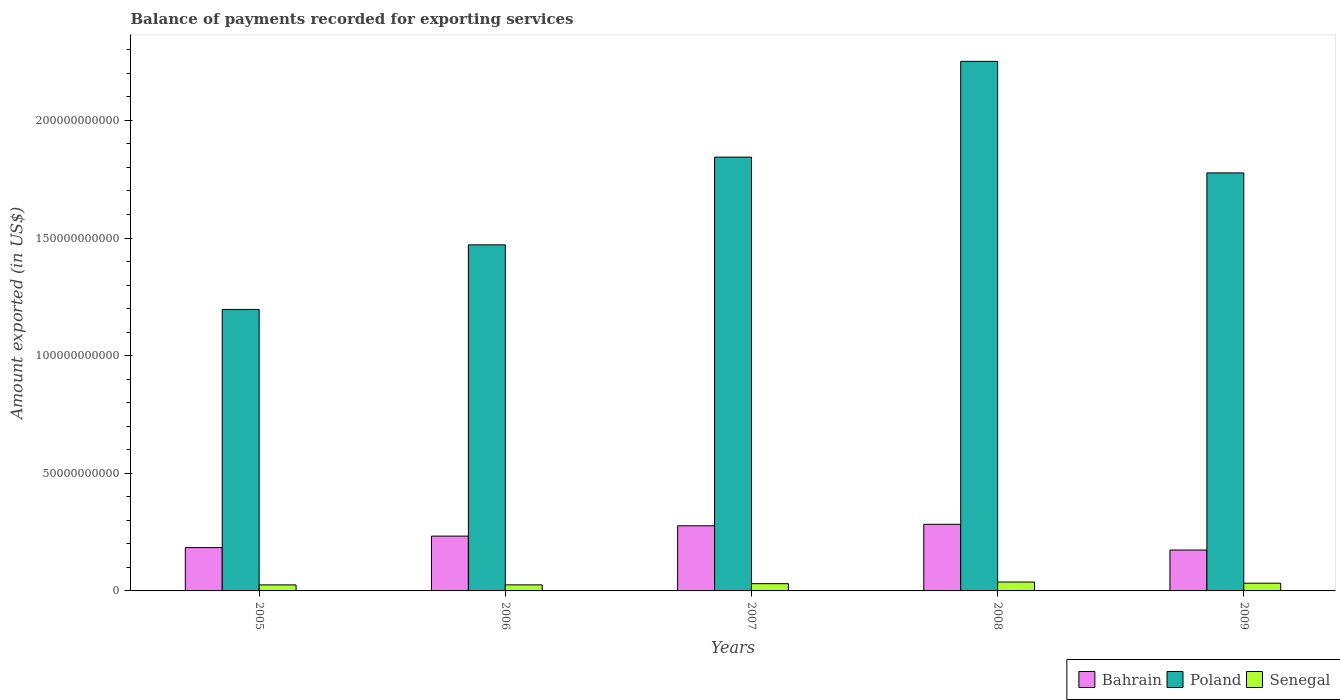How many different coloured bars are there?
Your answer should be very brief. 3. How many groups of bars are there?
Offer a terse response. 5. How many bars are there on the 4th tick from the left?
Offer a terse response. 3. How many bars are there on the 1st tick from the right?
Offer a terse response. 3. What is the label of the 3rd group of bars from the left?
Provide a short and direct response. 2007. What is the amount exported in Poland in 2009?
Offer a terse response. 1.78e+11. Across all years, what is the maximum amount exported in Bahrain?
Ensure brevity in your answer.  2.83e+1. Across all years, what is the minimum amount exported in Senegal?
Keep it short and to the point. 2.56e+09. In which year was the amount exported in Senegal minimum?
Provide a succinct answer. 2005. What is the total amount exported in Poland in the graph?
Offer a very short reply. 8.54e+11. What is the difference between the amount exported in Bahrain in 2005 and that in 2006?
Give a very brief answer. -4.88e+09. What is the difference between the amount exported in Poland in 2007 and the amount exported in Senegal in 2008?
Give a very brief answer. 1.81e+11. What is the average amount exported in Poland per year?
Offer a terse response. 1.71e+11. In the year 2009, what is the difference between the amount exported in Senegal and amount exported in Bahrain?
Offer a very short reply. -1.41e+1. In how many years, is the amount exported in Poland greater than 40000000000 US$?
Offer a very short reply. 5. What is the ratio of the amount exported in Bahrain in 2007 to that in 2009?
Keep it short and to the point. 1.59. Is the difference between the amount exported in Senegal in 2005 and 2006 greater than the difference between the amount exported in Bahrain in 2005 and 2006?
Give a very brief answer. Yes. What is the difference between the highest and the second highest amount exported in Senegal?
Your answer should be compact. 4.99e+08. What is the difference between the highest and the lowest amount exported in Bahrain?
Offer a very short reply. 1.09e+1. Is the sum of the amount exported in Bahrain in 2008 and 2009 greater than the maximum amount exported in Poland across all years?
Give a very brief answer. No. What does the 3rd bar from the left in 2005 represents?
Offer a terse response. Senegal. What does the 3rd bar from the right in 2007 represents?
Give a very brief answer. Bahrain. Is it the case that in every year, the sum of the amount exported in Senegal and amount exported in Bahrain is greater than the amount exported in Poland?
Keep it short and to the point. No. Does the graph contain any zero values?
Your answer should be very brief. No. Does the graph contain grids?
Keep it short and to the point. No. How are the legend labels stacked?
Your response must be concise. Horizontal. What is the title of the graph?
Make the answer very short. Balance of payments recorded for exporting services. What is the label or title of the X-axis?
Provide a succinct answer. Years. What is the label or title of the Y-axis?
Your response must be concise. Amount exported (in US$). What is the Amount exported (in US$) in Bahrain in 2005?
Keep it short and to the point. 1.84e+1. What is the Amount exported (in US$) of Poland in 2005?
Offer a terse response. 1.20e+11. What is the Amount exported (in US$) in Senegal in 2005?
Make the answer very short. 2.56e+09. What is the Amount exported (in US$) in Bahrain in 2006?
Ensure brevity in your answer.  2.33e+1. What is the Amount exported (in US$) in Poland in 2006?
Ensure brevity in your answer.  1.47e+11. What is the Amount exported (in US$) in Senegal in 2006?
Provide a short and direct response. 2.58e+09. What is the Amount exported (in US$) of Bahrain in 2007?
Make the answer very short. 2.77e+1. What is the Amount exported (in US$) of Poland in 2007?
Make the answer very short. 1.84e+11. What is the Amount exported (in US$) of Senegal in 2007?
Give a very brief answer. 3.08e+09. What is the Amount exported (in US$) of Bahrain in 2008?
Keep it short and to the point. 2.83e+1. What is the Amount exported (in US$) in Poland in 2008?
Provide a short and direct response. 2.25e+11. What is the Amount exported (in US$) in Senegal in 2008?
Offer a very short reply. 3.78e+09. What is the Amount exported (in US$) of Bahrain in 2009?
Your response must be concise. 1.74e+1. What is the Amount exported (in US$) of Poland in 2009?
Give a very brief answer. 1.78e+11. What is the Amount exported (in US$) of Senegal in 2009?
Make the answer very short. 3.29e+09. Across all years, what is the maximum Amount exported (in US$) in Bahrain?
Your response must be concise. 2.83e+1. Across all years, what is the maximum Amount exported (in US$) in Poland?
Provide a succinct answer. 2.25e+11. Across all years, what is the maximum Amount exported (in US$) of Senegal?
Your answer should be compact. 3.78e+09. Across all years, what is the minimum Amount exported (in US$) in Bahrain?
Provide a short and direct response. 1.74e+1. Across all years, what is the minimum Amount exported (in US$) in Poland?
Offer a terse response. 1.20e+11. Across all years, what is the minimum Amount exported (in US$) of Senegal?
Give a very brief answer. 2.56e+09. What is the total Amount exported (in US$) in Bahrain in the graph?
Provide a succinct answer. 1.15e+11. What is the total Amount exported (in US$) of Poland in the graph?
Offer a terse response. 8.54e+11. What is the total Amount exported (in US$) in Senegal in the graph?
Make the answer very short. 1.53e+1. What is the difference between the Amount exported (in US$) of Bahrain in 2005 and that in 2006?
Provide a succinct answer. -4.88e+09. What is the difference between the Amount exported (in US$) in Poland in 2005 and that in 2006?
Your answer should be compact. -2.75e+1. What is the difference between the Amount exported (in US$) in Senegal in 2005 and that in 2006?
Your answer should be compact. -1.45e+07. What is the difference between the Amount exported (in US$) in Bahrain in 2005 and that in 2007?
Your response must be concise. -9.28e+09. What is the difference between the Amount exported (in US$) in Poland in 2005 and that in 2007?
Keep it short and to the point. -6.47e+1. What is the difference between the Amount exported (in US$) of Senegal in 2005 and that in 2007?
Ensure brevity in your answer.  -5.14e+08. What is the difference between the Amount exported (in US$) in Bahrain in 2005 and that in 2008?
Your response must be concise. -9.91e+09. What is the difference between the Amount exported (in US$) of Poland in 2005 and that in 2008?
Provide a succinct answer. -1.05e+11. What is the difference between the Amount exported (in US$) of Senegal in 2005 and that in 2008?
Your answer should be very brief. -1.22e+09. What is the difference between the Amount exported (in US$) in Bahrain in 2005 and that in 2009?
Provide a succinct answer. 1.03e+09. What is the difference between the Amount exported (in US$) in Poland in 2005 and that in 2009?
Make the answer very short. -5.80e+1. What is the difference between the Amount exported (in US$) of Senegal in 2005 and that in 2009?
Provide a succinct answer. -7.24e+08. What is the difference between the Amount exported (in US$) in Bahrain in 2006 and that in 2007?
Provide a succinct answer. -4.39e+09. What is the difference between the Amount exported (in US$) of Poland in 2006 and that in 2007?
Provide a succinct answer. -3.73e+1. What is the difference between the Amount exported (in US$) in Senegal in 2006 and that in 2007?
Offer a terse response. -4.99e+08. What is the difference between the Amount exported (in US$) in Bahrain in 2006 and that in 2008?
Give a very brief answer. -5.02e+09. What is the difference between the Amount exported (in US$) of Poland in 2006 and that in 2008?
Give a very brief answer. -7.80e+1. What is the difference between the Amount exported (in US$) of Senegal in 2006 and that in 2008?
Your answer should be compact. -1.21e+09. What is the difference between the Amount exported (in US$) of Bahrain in 2006 and that in 2009?
Your answer should be very brief. 5.91e+09. What is the difference between the Amount exported (in US$) of Poland in 2006 and that in 2009?
Offer a terse response. -3.06e+1. What is the difference between the Amount exported (in US$) in Senegal in 2006 and that in 2009?
Your answer should be very brief. -7.10e+08. What is the difference between the Amount exported (in US$) in Bahrain in 2007 and that in 2008?
Keep it short and to the point. -6.31e+08. What is the difference between the Amount exported (in US$) of Poland in 2007 and that in 2008?
Provide a succinct answer. -4.07e+1. What is the difference between the Amount exported (in US$) in Senegal in 2007 and that in 2008?
Give a very brief answer. -7.09e+08. What is the difference between the Amount exported (in US$) of Bahrain in 2007 and that in 2009?
Your response must be concise. 1.03e+1. What is the difference between the Amount exported (in US$) of Poland in 2007 and that in 2009?
Offer a very short reply. 6.70e+09. What is the difference between the Amount exported (in US$) in Senegal in 2007 and that in 2009?
Ensure brevity in your answer.  -2.10e+08. What is the difference between the Amount exported (in US$) of Bahrain in 2008 and that in 2009?
Keep it short and to the point. 1.09e+1. What is the difference between the Amount exported (in US$) in Poland in 2008 and that in 2009?
Provide a short and direct response. 4.74e+1. What is the difference between the Amount exported (in US$) of Senegal in 2008 and that in 2009?
Provide a succinct answer. 4.99e+08. What is the difference between the Amount exported (in US$) of Bahrain in 2005 and the Amount exported (in US$) of Poland in 2006?
Your response must be concise. -1.29e+11. What is the difference between the Amount exported (in US$) in Bahrain in 2005 and the Amount exported (in US$) in Senegal in 2006?
Offer a terse response. 1.58e+1. What is the difference between the Amount exported (in US$) in Poland in 2005 and the Amount exported (in US$) in Senegal in 2006?
Your answer should be compact. 1.17e+11. What is the difference between the Amount exported (in US$) in Bahrain in 2005 and the Amount exported (in US$) in Poland in 2007?
Offer a very short reply. -1.66e+11. What is the difference between the Amount exported (in US$) in Bahrain in 2005 and the Amount exported (in US$) in Senegal in 2007?
Your answer should be compact. 1.53e+1. What is the difference between the Amount exported (in US$) of Poland in 2005 and the Amount exported (in US$) of Senegal in 2007?
Provide a succinct answer. 1.17e+11. What is the difference between the Amount exported (in US$) in Bahrain in 2005 and the Amount exported (in US$) in Poland in 2008?
Provide a succinct answer. -2.07e+11. What is the difference between the Amount exported (in US$) in Bahrain in 2005 and the Amount exported (in US$) in Senegal in 2008?
Your answer should be compact. 1.46e+1. What is the difference between the Amount exported (in US$) in Poland in 2005 and the Amount exported (in US$) in Senegal in 2008?
Give a very brief answer. 1.16e+11. What is the difference between the Amount exported (in US$) of Bahrain in 2005 and the Amount exported (in US$) of Poland in 2009?
Your response must be concise. -1.59e+11. What is the difference between the Amount exported (in US$) of Bahrain in 2005 and the Amount exported (in US$) of Senegal in 2009?
Your answer should be very brief. 1.51e+1. What is the difference between the Amount exported (in US$) of Poland in 2005 and the Amount exported (in US$) of Senegal in 2009?
Your answer should be compact. 1.16e+11. What is the difference between the Amount exported (in US$) of Bahrain in 2006 and the Amount exported (in US$) of Poland in 2007?
Your response must be concise. -1.61e+11. What is the difference between the Amount exported (in US$) in Bahrain in 2006 and the Amount exported (in US$) in Senegal in 2007?
Keep it short and to the point. 2.02e+1. What is the difference between the Amount exported (in US$) in Poland in 2006 and the Amount exported (in US$) in Senegal in 2007?
Make the answer very short. 1.44e+11. What is the difference between the Amount exported (in US$) of Bahrain in 2006 and the Amount exported (in US$) of Poland in 2008?
Your response must be concise. -2.02e+11. What is the difference between the Amount exported (in US$) in Bahrain in 2006 and the Amount exported (in US$) in Senegal in 2008?
Offer a very short reply. 1.95e+1. What is the difference between the Amount exported (in US$) in Poland in 2006 and the Amount exported (in US$) in Senegal in 2008?
Your response must be concise. 1.43e+11. What is the difference between the Amount exported (in US$) of Bahrain in 2006 and the Amount exported (in US$) of Poland in 2009?
Your response must be concise. -1.54e+11. What is the difference between the Amount exported (in US$) of Bahrain in 2006 and the Amount exported (in US$) of Senegal in 2009?
Ensure brevity in your answer.  2.00e+1. What is the difference between the Amount exported (in US$) in Poland in 2006 and the Amount exported (in US$) in Senegal in 2009?
Provide a short and direct response. 1.44e+11. What is the difference between the Amount exported (in US$) of Bahrain in 2007 and the Amount exported (in US$) of Poland in 2008?
Provide a short and direct response. -1.97e+11. What is the difference between the Amount exported (in US$) in Bahrain in 2007 and the Amount exported (in US$) in Senegal in 2008?
Make the answer very short. 2.39e+1. What is the difference between the Amount exported (in US$) of Poland in 2007 and the Amount exported (in US$) of Senegal in 2008?
Offer a very short reply. 1.81e+11. What is the difference between the Amount exported (in US$) of Bahrain in 2007 and the Amount exported (in US$) of Poland in 2009?
Make the answer very short. -1.50e+11. What is the difference between the Amount exported (in US$) of Bahrain in 2007 and the Amount exported (in US$) of Senegal in 2009?
Your answer should be very brief. 2.44e+1. What is the difference between the Amount exported (in US$) of Poland in 2007 and the Amount exported (in US$) of Senegal in 2009?
Ensure brevity in your answer.  1.81e+11. What is the difference between the Amount exported (in US$) in Bahrain in 2008 and the Amount exported (in US$) in Poland in 2009?
Make the answer very short. -1.49e+11. What is the difference between the Amount exported (in US$) in Bahrain in 2008 and the Amount exported (in US$) in Senegal in 2009?
Your response must be concise. 2.50e+1. What is the difference between the Amount exported (in US$) of Poland in 2008 and the Amount exported (in US$) of Senegal in 2009?
Your answer should be very brief. 2.22e+11. What is the average Amount exported (in US$) in Bahrain per year?
Provide a short and direct response. 2.30e+1. What is the average Amount exported (in US$) in Poland per year?
Give a very brief answer. 1.71e+11. What is the average Amount exported (in US$) in Senegal per year?
Give a very brief answer. 3.06e+09. In the year 2005, what is the difference between the Amount exported (in US$) in Bahrain and Amount exported (in US$) in Poland?
Give a very brief answer. -1.01e+11. In the year 2005, what is the difference between the Amount exported (in US$) in Bahrain and Amount exported (in US$) in Senegal?
Offer a very short reply. 1.59e+1. In the year 2005, what is the difference between the Amount exported (in US$) in Poland and Amount exported (in US$) in Senegal?
Offer a very short reply. 1.17e+11. In the year 2006, what is the difference between the Amount exported (in US$) in Bahrain and Amount exported (in US$) in Poland?
Ensure brevity in your answer.  -1.24e+11. In the year 2006, what is the difference between the Amount exported (in US$) of Bahrain and Amount exported (in US$) of Senegal?
Keep it short and to the point. 2.07e+1. In the year 2006, what is the difference between the Amount exported (in US$) of Poland and Amount exported (in US$) of Senegal?
Offer a terse response. 1.45e+11. In the year 2007, what is the difference between the Amount exported (in US$) of Bahrain and Amount exported (in US$) of Poland?
Ensure brevity in your answer.  -1.57e+11. In the year 2007, what is the difference between the Amount exported (in US$) of Bahrain and Amount exported (in US$) of Senegal?
Keep it short and to the point. 2.46e+1. In the year 2007, what is the difference between the Amount exported (in US$) of Poland and Amount exported (in US$) of Senegal?
Your answer should be compact. 1.81e+11. In the year 2008, what is the difference between the Amount exported (in US$) of Bahrain and Amount exported (in US$) of Poland?
Give a very brief answer. -1.97e+11. In the year 2008, what is the difference between the Amount exported (in US$) of Bahrain and Amount exported (in US$) of Senegal?
Provide a succinct answer. 2.45e+1. In the year 2008, what is the difference between the Amount exported (in US$) in Poland and Amount exported (in US$) in Senegal?
Your response must be concise. 2.21e+11. In the year 2009, what is the difference between the Amount exported (in US$) of Bahrain and Amount exported (in US$) of Poland?
Your response must be concise. -1.60e+11. In the year 2009, what is the difference between the Amount exported (in US$) of Bahrain and Amount exported (in US$) of Senegal?
Offer a terse response. 1.41e+1. In the year 2009, what is the difference between the Amount exported (in US$) of Poland and Amount exported (in US$) of Senegal?
Your answer should be compact. 1.74e+11. What is the ratio of the Amount exported (in US$) in Bahrain in 2005 to that in 2006?
Offer a terse response. 0.79. What is the ratio of the Amount exported (in US$) in Poland in 2005 to that in 2006?
Make the answer very short. 0.81. What is the ratio of the Amount exported (in US$) in Senegal in 2005 to that in 2006?
Provide a short and direct response. 0.99. What is the ratio of the Amount exported (in US$) of Bahrain in 2005 to that in 2007?
Give a very brief answer. 0.67. What is the ratio of the Amount exported (in US$) of Poland in 2005 to that in 2007?
Your response must be concise. 0.65. What is the ratio of the Amount exported (in US$) in Senegal in 2005 to that in 2007?
Your response must be concise. 0.83. What is the ratio of the Amount exported (in US$) of Bahrain in 2005 to that in 2008?
Provide a succinct answer. 0.65. What is the ratio of the Amount exported (in US$) of Poland in 2005 to that in 2008?
Your response must be concise. 0.53. What is the ratio of the Amount exported (in US$) of Senegal in 2005 to that in 2008?
Make the answer very short. 0.68. What is the ratio of the Amount exported (in US$) of Bahrain in 2005 to that in 2009?
Keep it short and to the point. 1.06. What is the ratio of the Amount exported (in US$) of Poland in 2005 to that in 2009?
Provide a succinct answer. 0.67. What is the ratio of the Amount exported (in US$) of Senegal in 2005 to that in 2009?
Your answer should be very brief. 0.78. What is the ratio of the Amount exported (in US$) in Bahrain in 2006 to that in 2007?
Your answer should be compact. 0.84. What is the ratio of the Amount exported (in US$) of Poland in 2006 to that in 2007?
Keep it short and to the point. 0.8. What is the ratio of the Amount exported (in US$) of Senegal in 2006 to that in 2007?
Your response must be concise. 0.84. What is the ratio of the Amount exported (in US$) of Bahrain in 2006 to that in 2008?
Ensure brevity in your answer.  0.82. What is the ratio of the Amount exported (in US$) of Poland in 2006 to that in 2008?
Your answer should be compact. 0.65. What is the ratio of the Amount exported (in US$) of Senegal in 2006 to that in 2008?
Your response must be concise. 0.68. What is the ratio of the Amount exported (in US$) of Bahrain in 2006 to that in 2009?
Give a very brief answer. 1.34. What is the ratio of the Amount exported (in US$) in Poland in 2006 to that in 2009?
Offer a terse response. 0.83. What is the ratio of the Amount exported (in US$) in Senegal in 2006 to that in 2009?
Your answer should be very brief. 0.78. What is the ratio of the Amount exported (in US$) of Bahrain in 2007 to that in 2008?
Offer a terse response. 0.98. What is the ratio of the Amount exported (in US$) in Poland in 2007 to that in 2008?
Offer a terse response. 0.82. What is the ratio of the Amount exported (in US$) in Senegal in 2007 to that in 2008?
Provide a succinct answer. 0.81. What is the ratio of the Amount exported (in US$) in Bahrain in 2007 to that in 2009?
Provide a succinct answer. 1.59. What is the ratio of the Amount exported (in US$) in Poland in 2007 to that in 2009?
Your answer should be compact. 1.04. What is the ratio of the Amount exported (in US$) in Senegal in 2007 to that in 2009?
Give a very brief answer. 0.94. What is the ratio of the Amount exported (in US$) in Bahrain in 2008 to that in 2009?
Ensure brevity in your answer.  1.63. What is the ratio of the Amount exported (in US$) in Poland in 2008 to that in 2009?
Provide a short and direct response. 1.27. What is the ratio of the Amount exported (in US$) of Senegal in 2008 to that in 2009?
Provide a short and direct response. 1.15. What is the difference between the highest and the second highest Amount exported (in US$) of Bahrain?
Your answer should be very brief. 6.31e+08. What is the difference between the highest and the second highest Amount exported (in US$) in Poland?
Offer a very short reply. 4.07e+1. What is the difference between the highest and the second highest Amount exported (in US$) in Senegal?
Your answer should be compact. 4.99e+08. What is the difference between the highest and the lowest Amount exported (in US$) in Bahrain?
Your answer should be compact. 1.09e+1. What is the difference between the highest and the lowest Amount exported (in US$) in Poland?
Offer a very short reply. 1.05e+11. What is the difference between the highest and the lowest Amount exported (in US$) in Senegal?
Give a very brief answer. 1.22e+09. 